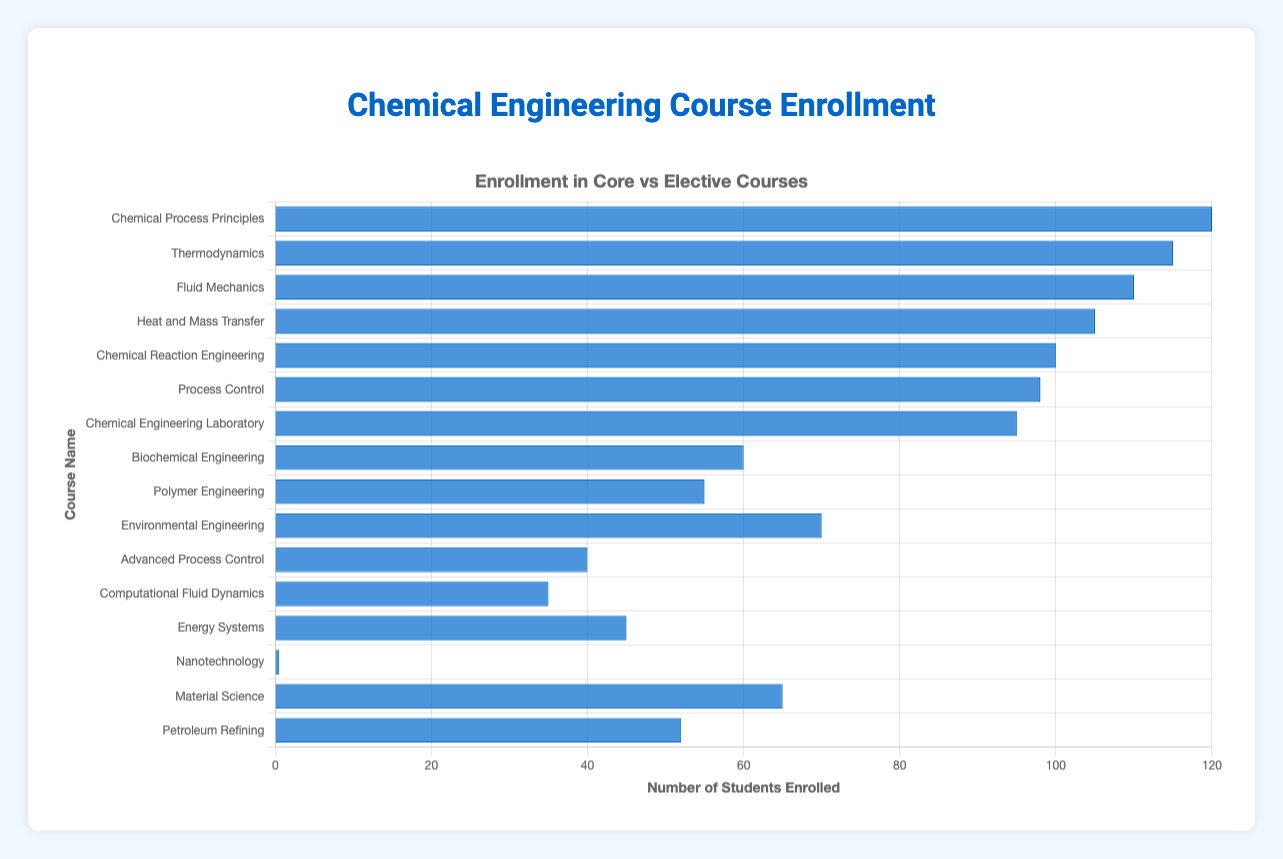What is the course with the highest enrollment? The bar chart indicates that 'Chemical Process Principles' has the tallest bar, representing the highest enrollment with 120 students.
Answer: Chemical Process Principles Which course has the least enrollment? According to the bar chart, 'Computational Fluid Dynamics' has the shortest bar, indicating the least enrollment with 35 students.
Answer: Computational Fluid Dynamics What is the total enrollment for all Core courses? The enrollments for Core courses are: 120, 115, 110, 105, 100, 98, 95. Adding these together gives 120 + 115 + 110 + 105 + 100 + 98 + 95 = 743.
Answer: 743 Compare the enrollment of Thermodynamics and Environmental Engineering. Which has more students? The bar for 'Thermodynamics' is longer than that for 'Environmental Engineering'. 'Thermodynamics' has 115 students, while 'Environmental Engineering' has 70.
Answer: Thermodynamics What's the average enrollment for Elective courses? The enrollments for Elective courses are: 60, 55, 70, 40, 35, 45, 50, 65, 52. Adding these together gives 60 + 55 + 70 + 40 + 35 + 45 + 50 + 65 + 52 = 472. There are 9 Elective courses, so the average is 472 / 9 ≈ 52.4.
Answer: 52.4 What is the difference in enrollment between the Core course with the highest enrollment and the Elective course with the highest enrollment? The Core course with the highest enrollment is 'Chemical Process Principles' with 120 students. The Elective course with the highest enrollment is 'Environmental Engineering' with 70 students. The difference is 120 - 70 = 50.
Answer: 50 Which Core courses have enrollments greater than 100? From the figure, the Core courses with bars extending past the 100 mark are 'Chemical Process Principles' (120), 'Thermodynamics' (115), 'Fluid Mechanics' (110), and 'Heat and Mass Transfer' (105).
Answer: Chemical Process Principles, Thermodynamics, Fluid Mechanics, Heat and Mass Transfer How does the enrollment of Process Control compare to Advanced Process Control? 'Process Control' is a Core course with an enrollment of 98, and 'Advanced Process Control' is an Elective course with 40. The bar for 'Process Control' is much longer, indicating 'Process Control' has more students.
Answer: Process Control What's the ratio of average enrollment between Core and Elective courses? Average enrollment for Core courses: (120 + 115 + 110 + 105 + 100 + 98 + 95) / 7 = 743 / 7 ≈ 106.1. Average enrollment for Elective courses: (60 + 55 + 70 + 40 + 35 + 45 + 50 + 65 + 52) / 9 = 472 / 9 ≈ 52.4. The ratio is 106.1 / 52.4 ≈ 2.02.
Answer: 2.02 